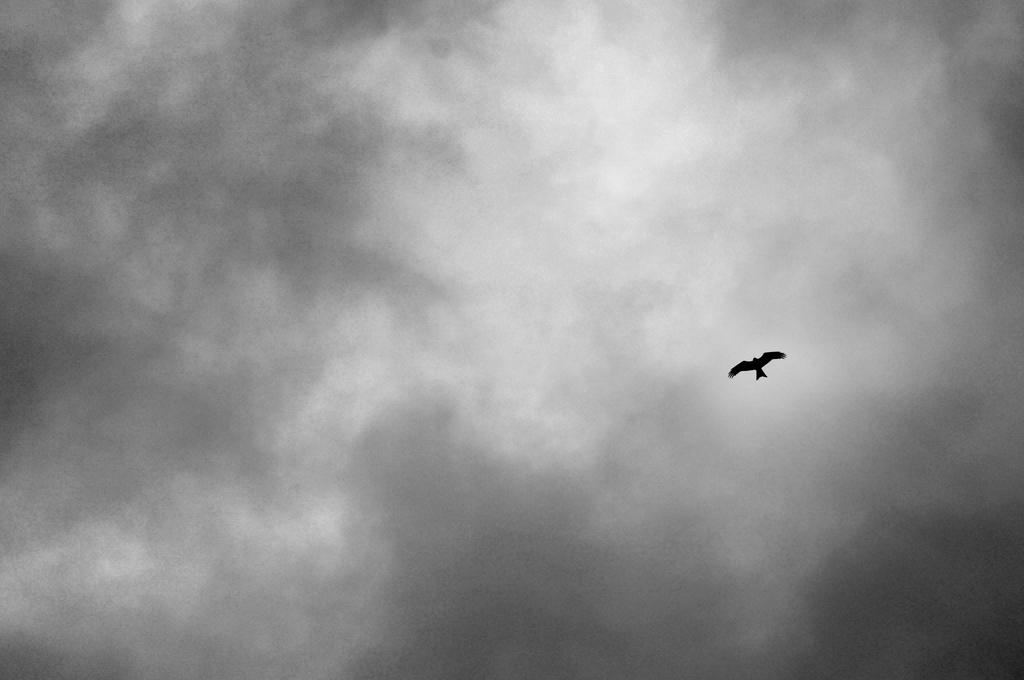What type of animal is present in the image? There is a bird in the image. What is visible in the background of the image? The sky is visible in the image. How would you describe the sky in the image? The sky appears to be cloudy in the image. What is the color scheme of the image? The image is black and white in color. Is there any jam visible in the image? There is no jam present in the image. Can you describe the intensity of the rainstorm in the image? There is no rainstorm present in the image; it is a black and white image of a bird and a cloudy sky. 